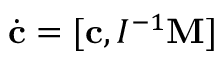Convert formula to latex. <formula><loc_0><loc_0><loc_500><loc_500>\dot { c } = [ { c } , I ^ { - 1 } { M } ]</formula> 